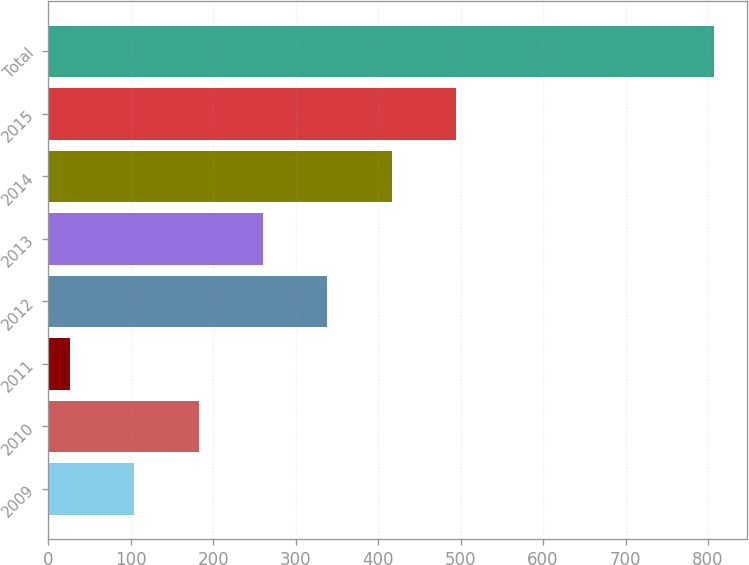Convert chart. <chart><loc_0><loc_0><loc_500><loc_500><bar_chart><fcel>2009<fcel>2010<fcel>2011<fcel>2012<fcel>2013<fcel>2014<fcel>2015<fcel>Total<nl><fcel>104.1<fcel>182.2<fcel>26<fcel>338.4<fcel>260.3<fcel>416.5<fcel>494.6<fcel>807<nl></chart> 